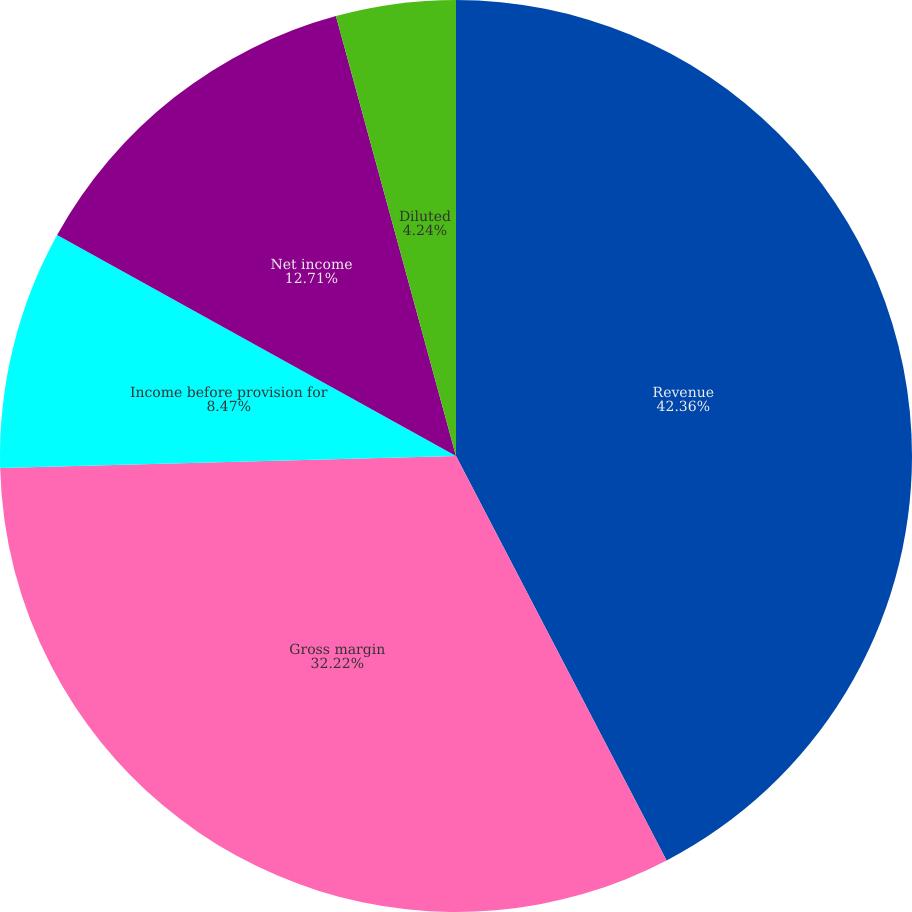Convert chart to OTSL. <chart><loc_0><loc_0><loc_500><loc_500><pie_chart><fcel>Revenue<fcel>Gross margin<fcel>Income before provision for<fcel>Net income<fcel>Basic<fcel>Diluted<nl><fcel>42.36%<fcel>32.22%<fcel>8.47%<fcel>12.71%<fcel>0.0%<fcel>4.24%<nl></chart> 